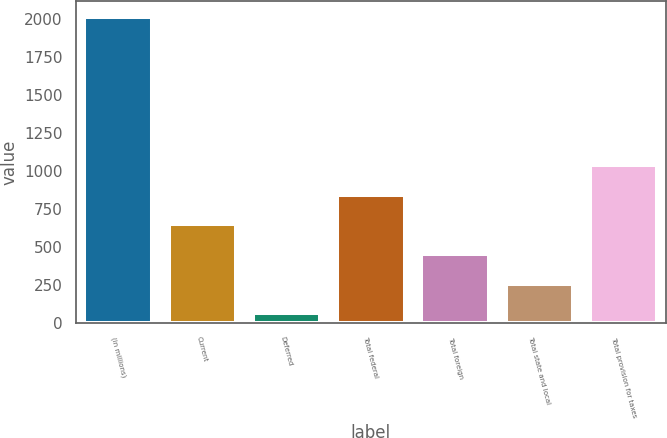Convert chart to OTSL. <chart><loc_0><loc_0><loc_500><loc_500><bar_chart><fcel>(in millions)<fcel>Current<fcel>Deferred<fcel>Total federal<fcel>Total foreign<fcel>Total state and local<fcel>Total provision for taxes<nl><fcel>2017<fcel>649.2<fcel>63<fcel>844.6<fcel>453.8<fcel>258.4<fcel>1040<nl></chart> 